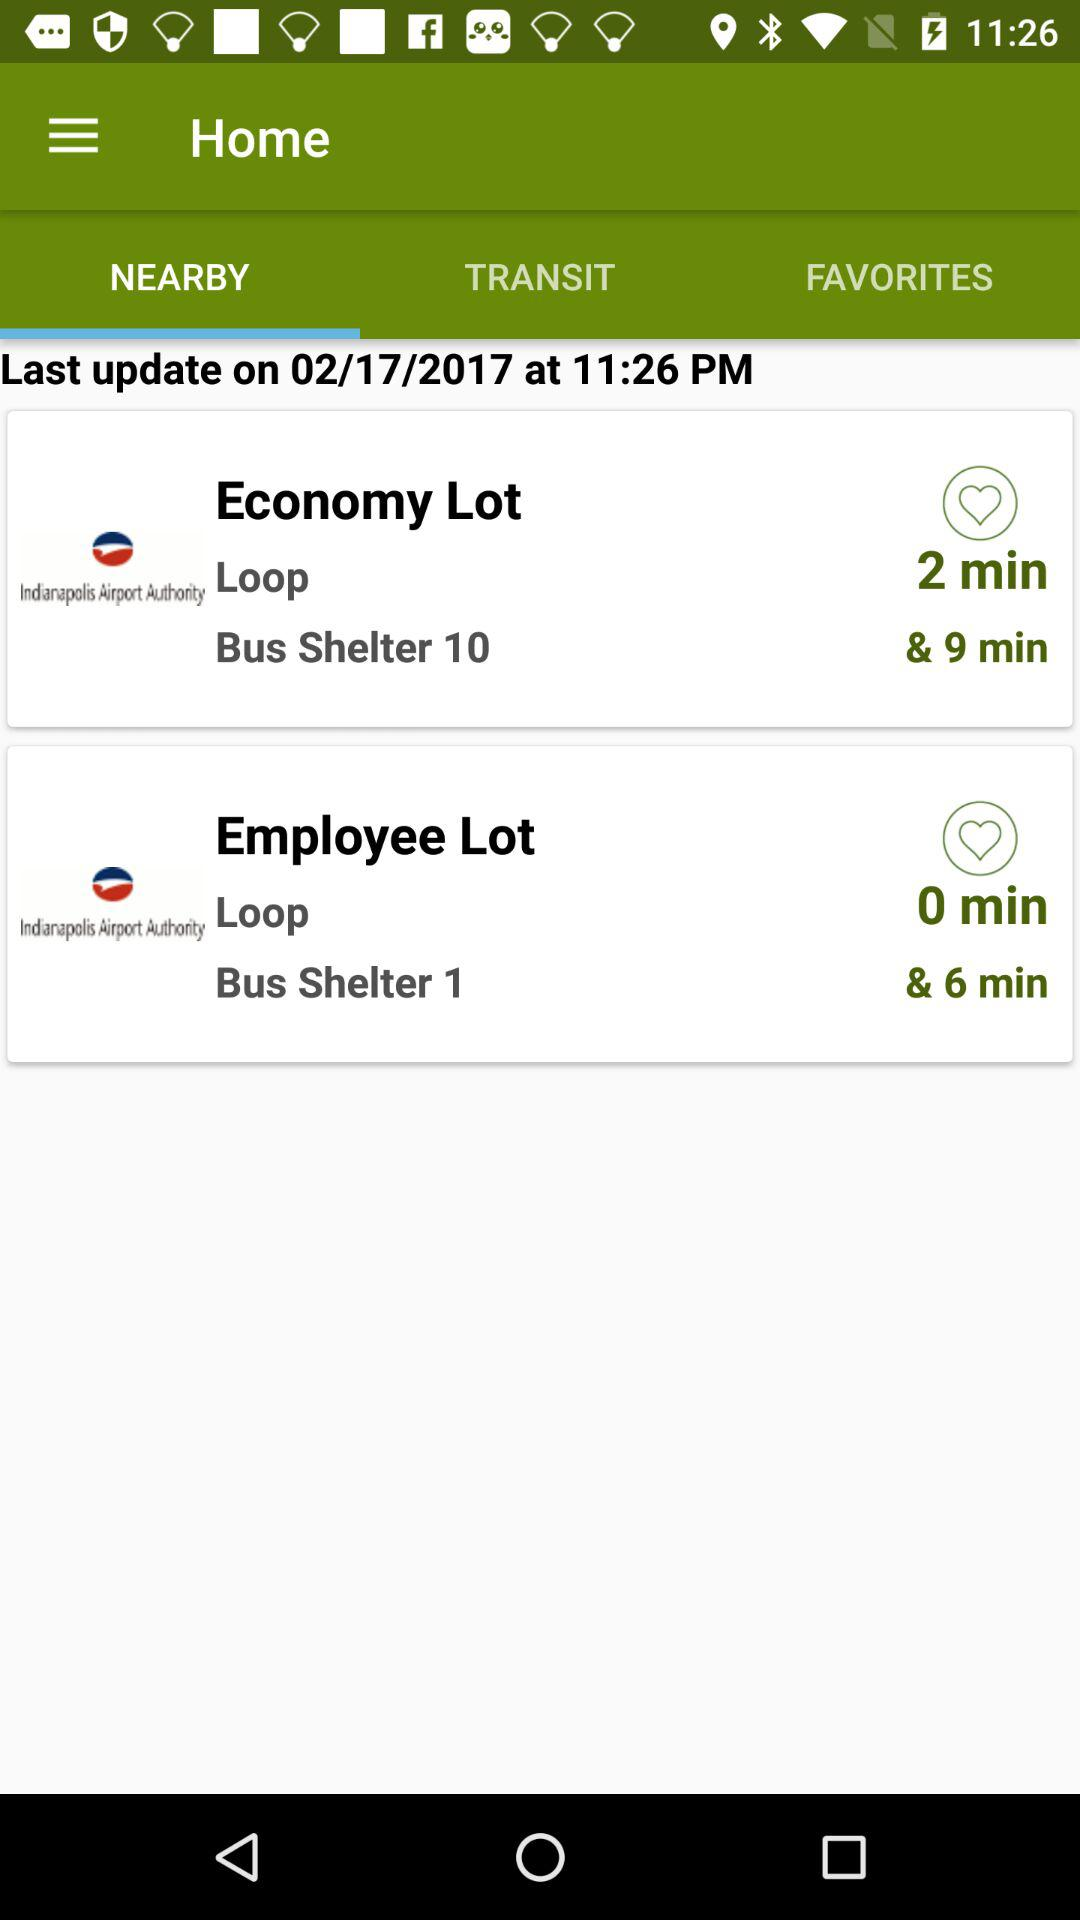What is the date of the last update? The date of the last update is February 17, 2017. 